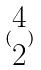Convert formula to latex. <formula><loc_0><loc_0><loc_500><loc_500>( \begin{matrix} 4 \\ 2 \end{matrix} )</formula> 